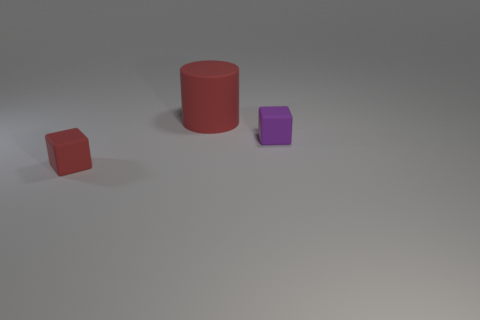Add 1 red things. How many objects exist? 4 Subtract all cylinders. How many objects are left? 2 Subtract 0 green blocks. How many objects are left? 3 Subtract all purple matte objects. Subtract all big red cylinders. How many objects are left? 1 Add 3 rubber cylinders. How many rubber cylinders are left? 4 Add 1 small cyan matte cubes. How many small cyan matte cubes exist? 1 